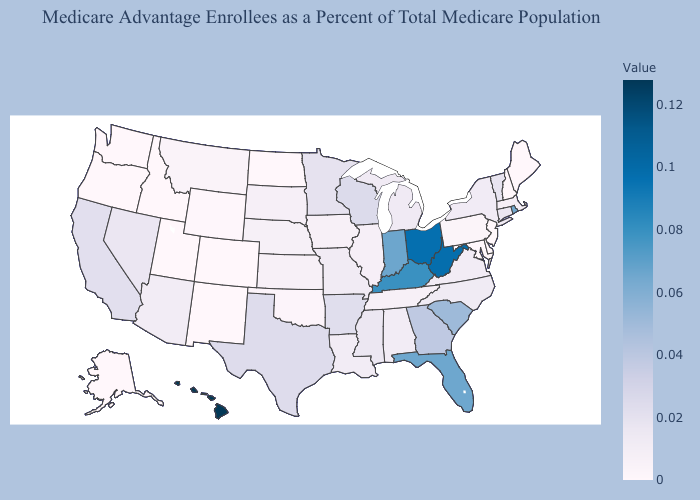Does Texas have the highest value in the South?
Quick response, please. No. Does Idaho have a lower value than California?
Write a very short answer. Yes. Among the states that border Idaho , does Utah have the lowest value?
Short answer required. Yes. Does the map have missing data?
Quick response, please. No. Which states hav the highest value in the Northeast?
Keep it brief. Rhode Island. Does West Virginia have the lowest value in the USA?
Concise answer only. No. 